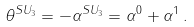<formula> <loc_0><loc_0><loc_500><loc_500>\theta ^ { S U _ { 3 } } = - \alpha ^ { S U _ { 3 } } = \alpha ^ { 0 } + \alpha ^ { 1 } \, .</formula> 